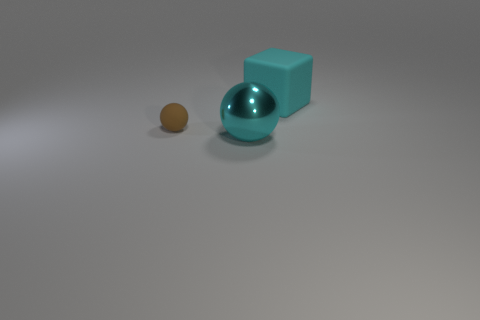Add 1 big green metallic blocks. How many objects exist? 4 Subtract all blocks. How many objects are left? 2 Subtract 0 cyan cylinders. How many objects are left? 3 Subtract all cyan matte objects. Subtract all blue balls. How many objects are left? 2 Add 1 brown matte objects. How many brown matte objects are left? 2 Add 2 rubber cylinders. How many rubber cylinders exist? 2 